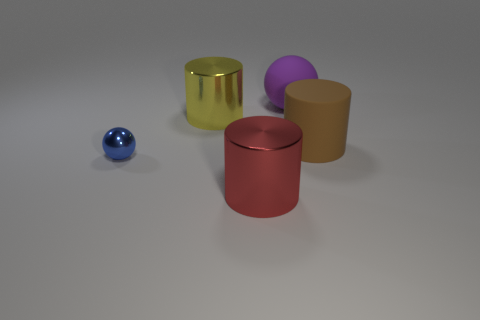Are there any other things that are the same size as the blue shiny object?
Ensure brevity in your answer.  No. Is there a purple thing of the same size as the yellow object?
Your response must be concise. Yes. The large object that is right of the big purple rubber thing is what color?
Give a very brief answer. Brown. The object that is both right of the small thing and in front of the large brown thing has what shape?
Provide a succinct answer. Cylinder. How many big yellow shiny objects are the same shape as the large red object?
Make the answer very short. 1. How many big purple rubber cubes are there?
Your answer should be compact. 0. How big is the object that is behind the big brown matte cylinder and in front of the purple object?
Provide a short and direct response. Large. There is a brown object that is the same size as the yellow cylinder; what is its shape?
Provide a short and direct response. Cylinder. There is a large red shiny object in front of the blue shiny sphere; are there any purple rubber balls in front of it?
Make the answer very short. No. What color is the other thing that is the same shape as the small blue metallic thing?
Your response must be concise. Purple. 